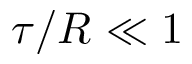<formula> <loc_0><loc_0><loc_500><loc_500>\tau / R \ll 1</formula> 